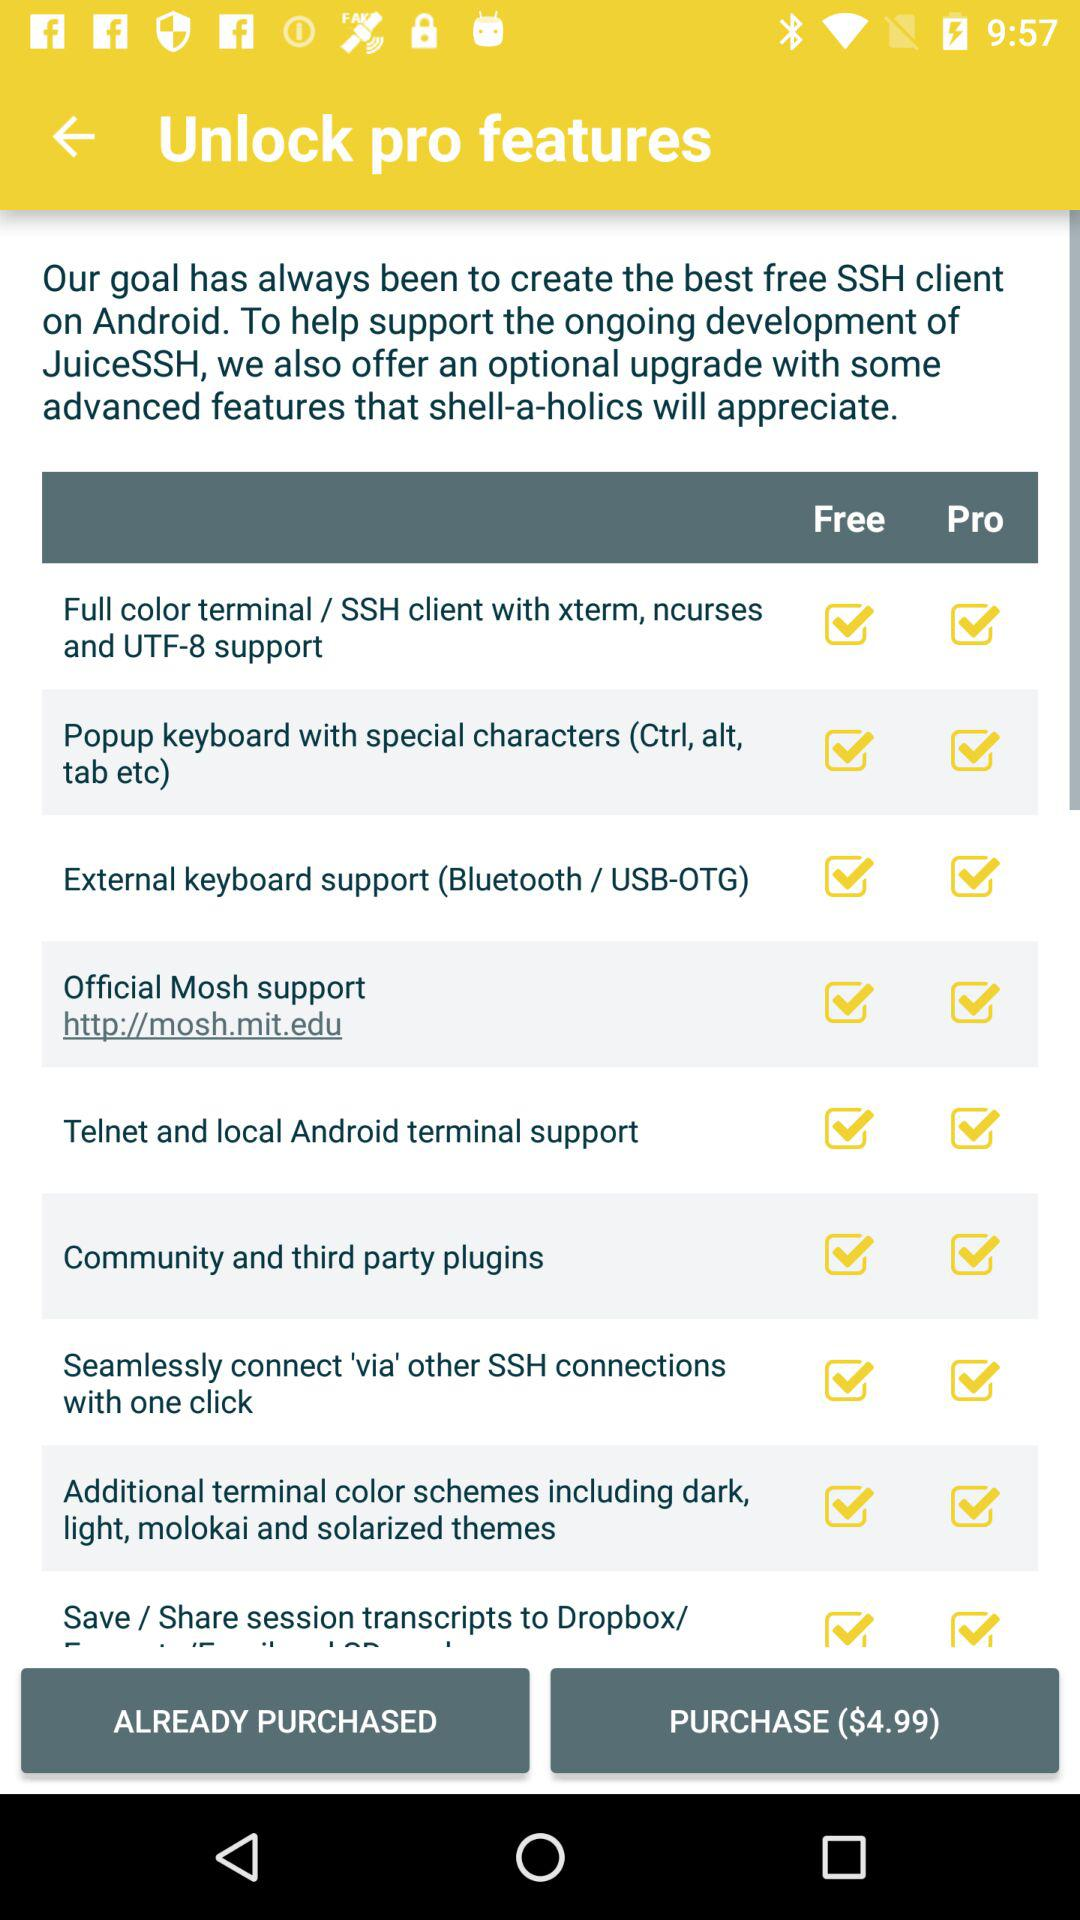Is community and third party plugins free or paid?
When the provided information is insufficient, respond with <no answer>. <no answer> 